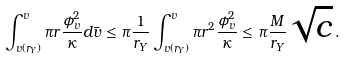<formula> <loc_0><loc_0><loc_500><loc_500>\int _ { v \left ( r _ { Y } \right ) } ^ { v } \pi r \frac { \phi _ { v } ^ { 2 } } { \kappa } d \bar { v } \leq \pi \frac { 1 } { r _ { Y } } \int _ { v \left ( r _ { Y } \right ) } ^ { v } \pi r ^ { 2 } \frac { \phi _ { v } ^ { 2 } } { \kappa } \leq \pi \frac { M } { r _ { Y } } \sqrt { c } \, .</formula> 